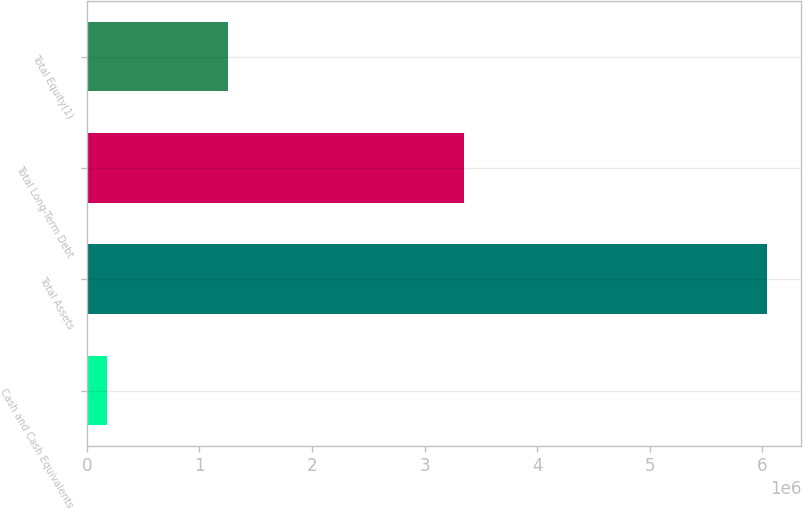Convert chart to OTSL. <chart><loc_0><loc_0><loc_500><loc_500><bar_chart><fcel>Cash and Cash Equivalents<fcel>Total Assets<fcel>Total Long-Term Debt<fcel>Total Equity(1)<nl><fcel>179845<fcel>6.04126e+06<fcel>3.35359e+06<fcel>1.25426e+06<nl></chart> 